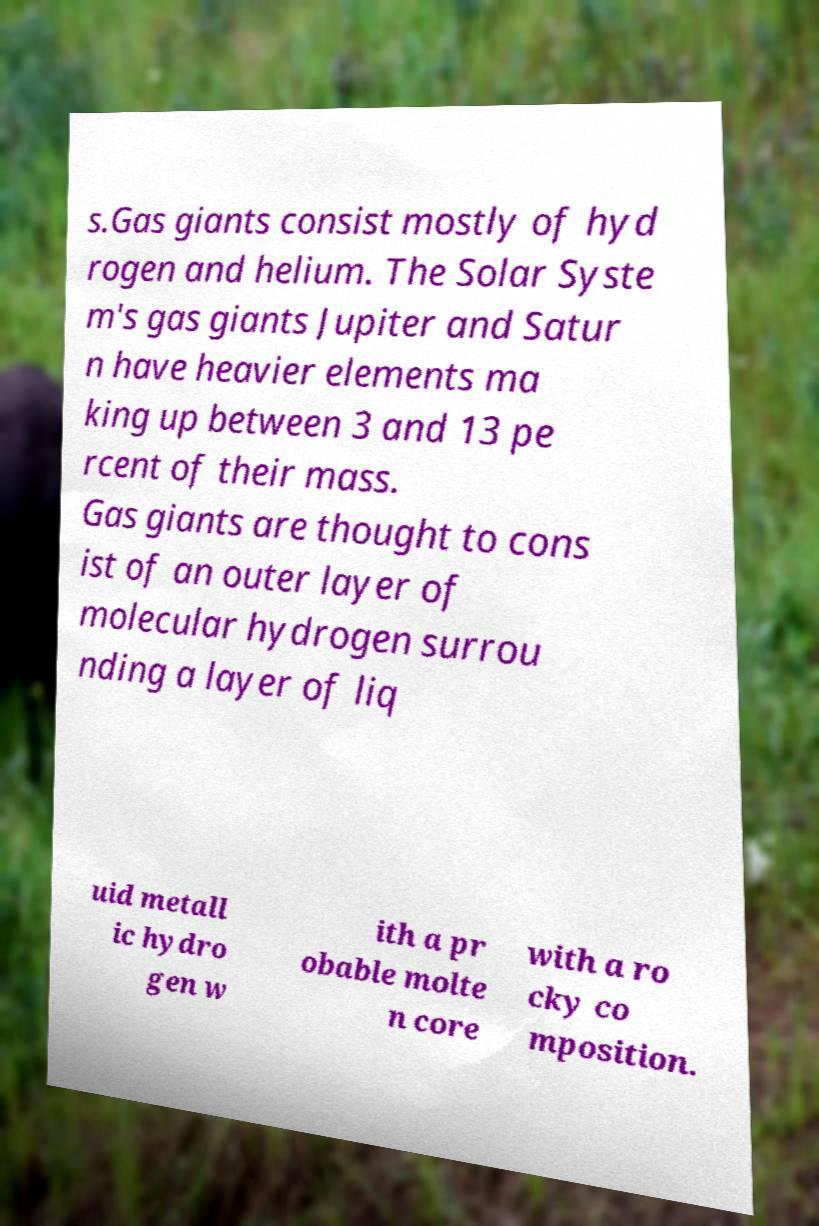Could you extract and type out the text from this image? s.Gas giants consist mostly of hyd rogen and helium. The Solar Syste m's gas giants Jupiter and Satur n have heavier elements ma king up between 3 and 13 pe rcent of their mass. Gas giants are thought to cons ist of an outer layer of molecular hydrogen surrou nding a layer of liq uid metall ic hydro gen w ith a pr obable molte n core with a ro cky co mposition. 